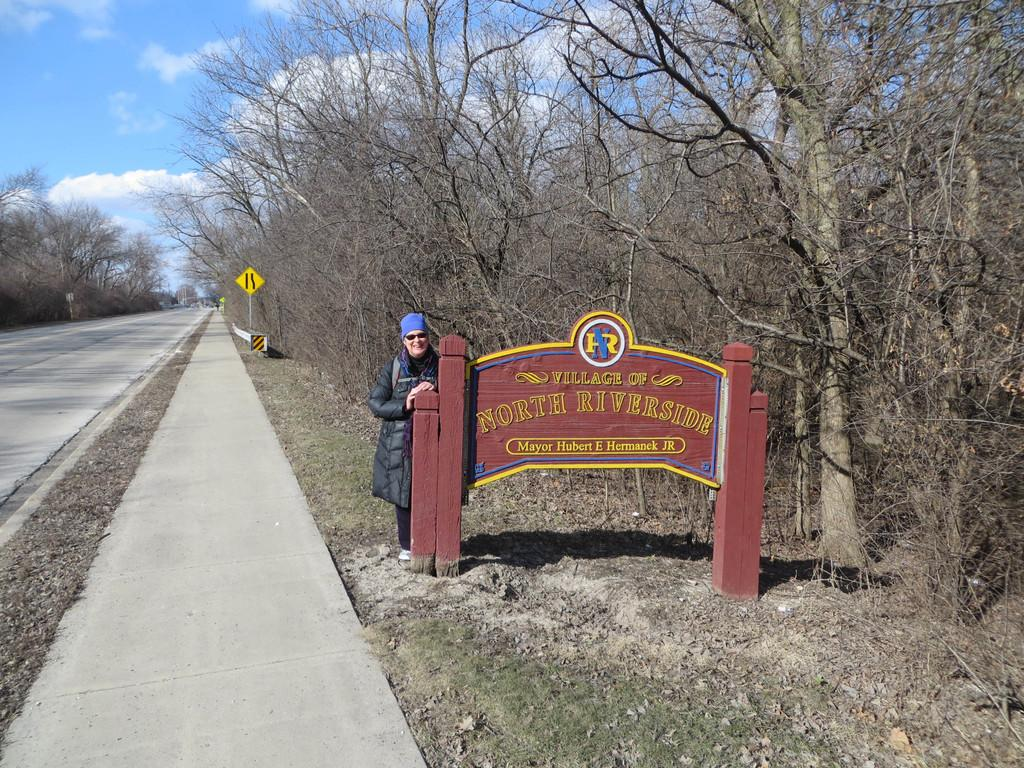Provide a one-sentence caption for the provided image. A plaque reading Village of North Riverside welcomes visitors. 